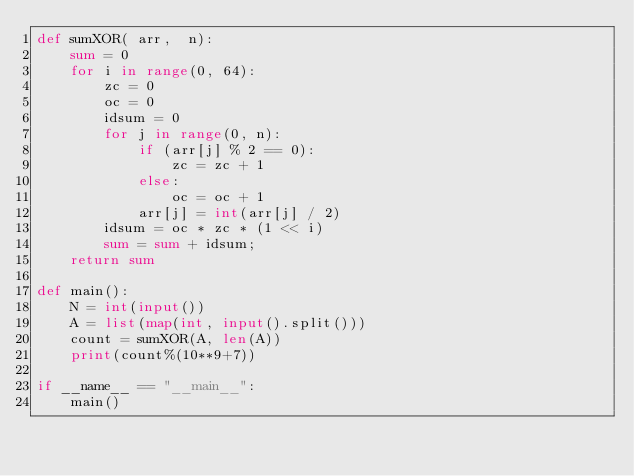Convert code to text. <code><loc_0><loc_0><loc_500><loc_500><_Python_>def sumXOR( arr,  n): 
    sum = 0
    for i in range(0, 64): 
        zc = 0
        oc = 0
        idsum = 0
        for j in range(0, n): 
            if (arr[j] % 2 == 0): 
                zc = zc + 1
            else: 
                oc = oc + 1
            arr[j] = int(arr[j] / 2) 
        idsum = oc * zc * (1 << i) 
        sum = sum + idsum;        
    return sum
  
def main():
    N = int(input())
    A = list(map(int, input().split()))
    count = sumXOR(A, len(A))
    print(count%(10**9+7))

if __name__ == "__main__":
    main()
</code> 